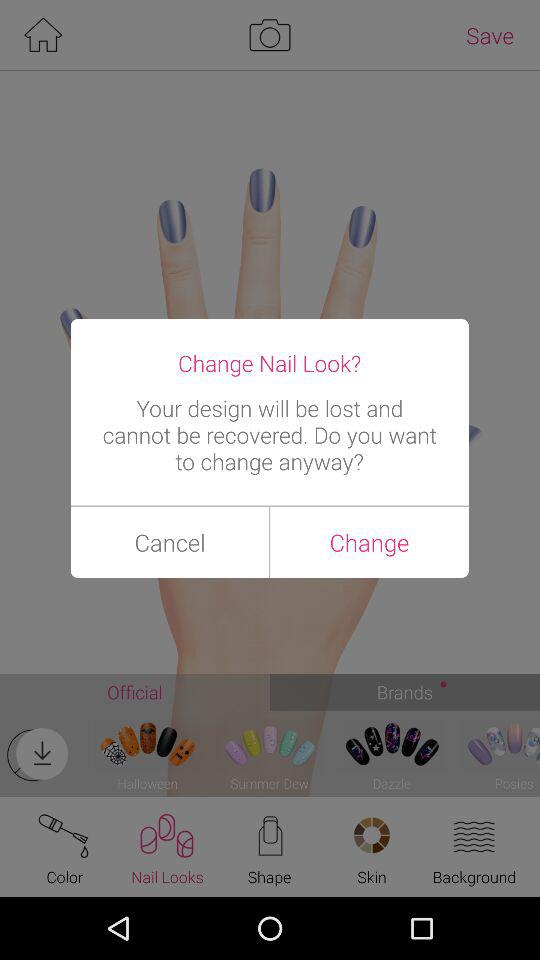Which is the selected tab? The selected tab is "Nail Looks". 